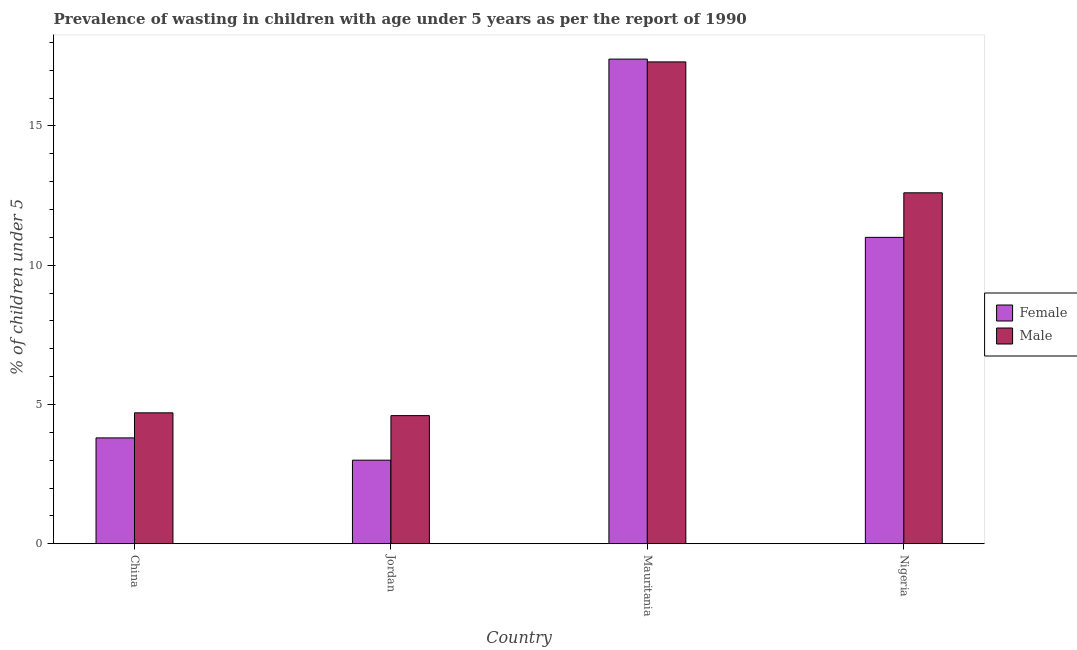How many groups of bars are there?
Your response must be concise. 4. What is the label of the 4th group of bars from the left?
Offer a terse response. Nigeria. In how many cases, is the number of bars for a given country not equal to the number of legend labels?
Make the answer very short. 0. What is the percentage of undernourished male children in Mauritania?
Give a very brief answer. 17.3. Across all countries, what is the maximum percentage of undernourished female children?
Your response must be concise. 17.4. Across all countries, what is the minimum percentage of undernourished male children?
Offer a terse response. 4.6. In which country was the percentage of undernourished female children maximum?
Provide a succinct answer. Mauritania. In which country was the percentage of undernourished male children minimum?
Make the answer very short. Jordan. What is the total percentage of undernourished female children in the graph?
Provide a short and direct response. 35.2. What is the difference between the percentage of undernourished female children in China and that in Nigeria?
Make the answer very short. -7.2. What is the difference between the percentage of undernourished male children in Jordan and the percentage of undernourished female children in Nigeria?
Keep it short and to the point. -6.4. What is the average percentage of undernourished female children per country?
Provide a short and direct response. 8.8. What is the difference between the percentage of undernourished female children and percentage of undernourished male children in Nigeria?
Ensure brevity in your answer.  -1.6. In how many countries, is the percentage of undernourished male children greater than 6 %?
Provide a short and direct response. 2. What is the ratio of the percentage of undernourished male children in Mauritania to that in Nigeria?
Offer a terse response. 1.37. Is the difference between the percentage of undernourished female children in Jordan and Mauritania greater than the difference between the percentage of undernourished male children in Jordan and Mauritania?
Ensure brevity in your answer.  No. What is the difference between the highest and the second highest percentage of undernourished female children?
Your answer should be very brief. 6.4. What is the difference between the highest and the lowest percentage of undernourished male children?
Keep it short and to the point. 12.7. What does the 2nd bar from the right in Nigeria represents?
Your response must be concise. Female. Are the values on the major ticks of Y-axis written in scientific E-notation?
Provide a short and direct response. No. Where does the legend appear in the graph?
Make the answer very short. Center right. How are the legend labels stacked?
Provide a succinct answer. Vertical. What is the title of the graph?
Keep it short and to the point. Prevalence of wasting in children with age under 5 years as per the report of 1990. What is the label or title of the X-axis?
Ensure brevity in your answer.  Country. What is the label or title of the Y-axis?
Provide a short and direct response.  % of children under 5. What is the  % of children under 5 of Female in China?
Provide a succinct answer. 3.8. What is the  % of children under 5 in Male in China?
Your response must be concise. 4.7. What is the  % of children under 5 of Female in Jordan?
Give a very brief answer. 3. What is the  % of children under 5 of Male in Jordan?
Your answer should be very brief. 4.6. What is the  % of children under 5 in Female in Mauritania?
Ensure brevity in your answer.  17.4. What is the  % of children under 5 of Male in Mauritania?
Your response must be concise. 17.3. What is the  % of children under 5 of Female in Nigeria?
Your answer should be very brief. 11. What is the  % of children under 5 of Male in Nigeria?
Your answer should be very brief. 12.6. Across all countries, what is the maximum  % of children under 5 of Female?
Your answer should be very brief. 17.4. Across all countries, what is the maximum  % of children under 5 in Male?
Keep it short and to the point. 17.3. Across all countries, what is the minimum  % of children under 5 in Male?
Provide a succinct answer. 4.6. What is the total  % of children under 5 in Female in the graph?
Your response must be concise. 35.2. What is the total  % of children under 5 of Male in the graph?
Provide a short and direct response. 39.2. What is the difference between the  % of children under 5 in Female in China and that in Jordan?
Offer a very short reply. 0.8. What is the difference between the  % of children under 5 in Female in China and that in Mauritania?
Your answer should be compact. -13.6. What is the difference between the  % of children under 5 in Male in China and that in Mauritania?
Provide a succinct answer. -12.6. What is the difference between the  % of children under 5 in Female in China and that in Nigeria?
Give a very brief answer. -7.2. What is the difference between the  % of children under 5 of Male in China and that in Nigeria?
Provide a short and direct response. -7.9. What is the difference between the  % of children under 5 of Female in Jordan and that in Mauritania?
Offer a very short reply. -14.4. What is the difference between the  % of children under 5 in Male in Jordan and that in Mauritania?
Provide a short and direct response. -12.7. What is the difference between the  % of children under 5 of Male in Mauritania and that in Nigeria?
Provide a succinct answer. 4.7. What is the difference between the  % of children under 5 in Female in China and the  % of children under 5 in Male in Mauritania?
Your response must be concise. -13.5. What is the difference between the  % of children under 5 of Female in Jordan and the  % of children under 5 of Male in Mauritania?
Provide a succinct answer. -14.3. What is the difference between the  % of children under 5 in Female in Mauritania and the  % of children under 5 in Male in Nigeria?
Provide a succinct answer. 4.8. What is the difference between the  % of children under 5 in Female and  % of children under 5 in Male in Mauritania?
Your response must be concise. 0.1. What is the ratio of the  % of children under 5 of Female in China to that in Jordan?
Give a very brief answer. 1.27. What is the ratio of the  % of children under 5 in Male in China to that in Jordan?
Your answer should be very brief. 1.02. What is the ratio of the  % of children under 5 of Female in China to that in Mauritania?
Provide a succinct answer. 0.22. What is the ratio of the  % of children under 5 of Male in China to that in Mauritania?
Offer a terse response. 0.27. What is the ratio of the  % of children under 5 in Female in China to that in Nigeria?
Your answer should be very brief. 0.35. What is the ratio of the  % of children under 5 in Male in China to that in Nigeria?
Ensure brevity in your answer.  0.37. What is the ratio of the  % of children under 5 in Female in Jordan to that in Mauritania?
Make the answer very short. 0.17. What is the ratio of the  % of children under 5 of Male in Jordan to that in Mauritania?
Give a very brief answer. 0.27. What is the ratio of the  % of children under 5 of Female in Jordan to that in Nigeria?
Offer a terse response. 0.27. What is the ratio of the  % of children under 5 of Male in Jordan to that in Nigeria?
Your response must be concise. 0.37. What is the ratio of the  % of children under 5 in Female in Mauritania to that in Nigeria?
Ensure brevity in your answer.  1.58. What is the ratio of the  % of children under 5 in Male in Mauritania to that in Nigeria?
Your answer should be compact. 1.37. What is the difference between the highest and the second highest  % of children under 5 in Female?
Offer a very short reply. 6.4. What is the difference between the highest and the second highest  % of children under 5 in Male?
Provide a short and direct response. 4.7. What is the difference between the highest and the lowest  % of children under 5 of Male?
Ensure brevity in your answer.  12.7. 